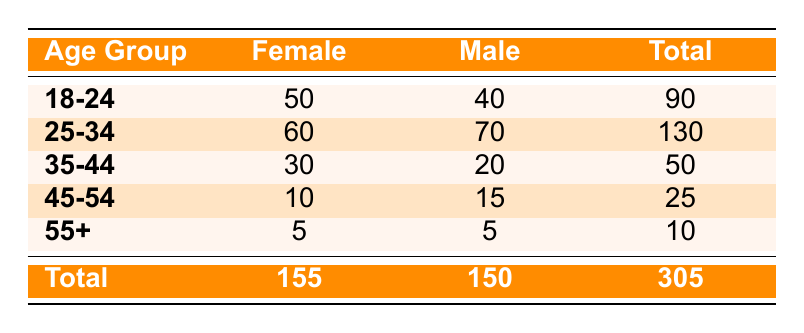What is the total number of female customers in the 25-34 age group? The table shows that the frequency for female customers in the 25-34 age group is 60.
Answer: 60 What is the total number of male customers in the 18-24 age group? According to the table, the frequency for male customers in the 18-24 age group is indicated as 40.
Answer: 40 Which age group has the highest total number of customers? By adding the total customers for each age group: 90 for 18-24, 130 for 25-34, 50 for 35-44, 25 for 45-54, and 10 for 55+. The age group 25-34 has the highest total with 130 customers.
Answer: 25-34 Are there more female customers or male customers in the restaurant overall? The total number of female customers is 155, and the total number of male customers is 150. Since 155 is greater than 150, there are more female customers overall.
Answer: Yes What is the frequency difference between male and female customers in the 45-54 age group? The frequency of male customers in the 45-54 age group is 15, while for female customers it is 10. The difference is calculated by subtracting 10 from 15, which results in 5.
Answer: 5 What is the average number of customers for each gender across all age groups? To find the average, sum the total number of female customers (155) and male customers (150), giving 305. Then, divide by the number of age groups (5), which results in an average of 61 customers overall for each gender (305/5 = 61).
Answer: 61 How many customers are aged 55 or older? The total number of customers in the 55+ age group is the sum of female and male customers, which is 5 (female) + 5 (male) = 10.
Answer: 10 Is the total frequency of male customers in age groups 35-44 and 45-54 combined greater than that of the 18-24 age group? In the 35-44 age group, there are 20 males, and in the 45-54 age group, there are 15 males. Combined, these give 20 + 15 = 35. The frequency for the 18-24 age group is 40 male customers. Since 35 is less than 40, the combined total is not greater than that of the 18-24 age group.
Answer: No 